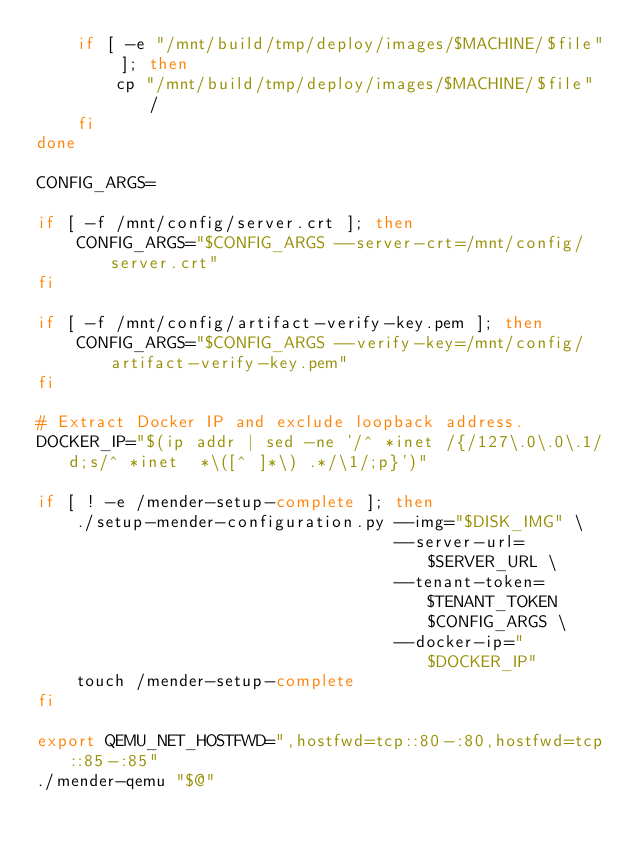<code> <loc_0><loc_0><loc_500><loc_500><_Bash_>    if [ -e "/mnt/build/tmp/deploy/images/$MACHINE/$file" ]; then
        cp "/mnt/build/tmp/deploy/images/$MACHINE/$file" /
    fi
done

CONFIG_ARGS=

if [ -f /mnt/config/server.crt ]; then
    CONFIG_ARGS="$CONFIG_ARGS --server-crt=/mnt/config/server.crt"
fi

if [ -f /mnt/config/artifact-verify-key.pem ]; then
    CONFIG_ARGS="$CONFIG_ARGS --verify-key=/mnt/config/artifact-verify-key.pem"
fi

# Extract Docker IP and exclude loopback address.
DOCKER_IP="$(ip addr | sed -ne '/^ *inet /{/127\.0\.0\.1/d;s/^ *inet  *\([^ ]*\) .*/\1/;p}')"

if [ ! -e /mender-setup-complete ]; then
    ./setup-mender-configuration.py --img="$DISK_IMG" \
                                    --server-url=$SERVER_URL \
                                    --tenant-token=$TENANT_TOKEN $CONFIG_ARGS \
                                    --docker-ip="$DOCKER_IP"
    touch /mender-setup-complete
fi

export QEMU_NET_HOSTFWD=",hostfwd=tcp::80-:80,hostfwd=tcp::85-:85"
./mender-qemu "$@"
</code> 